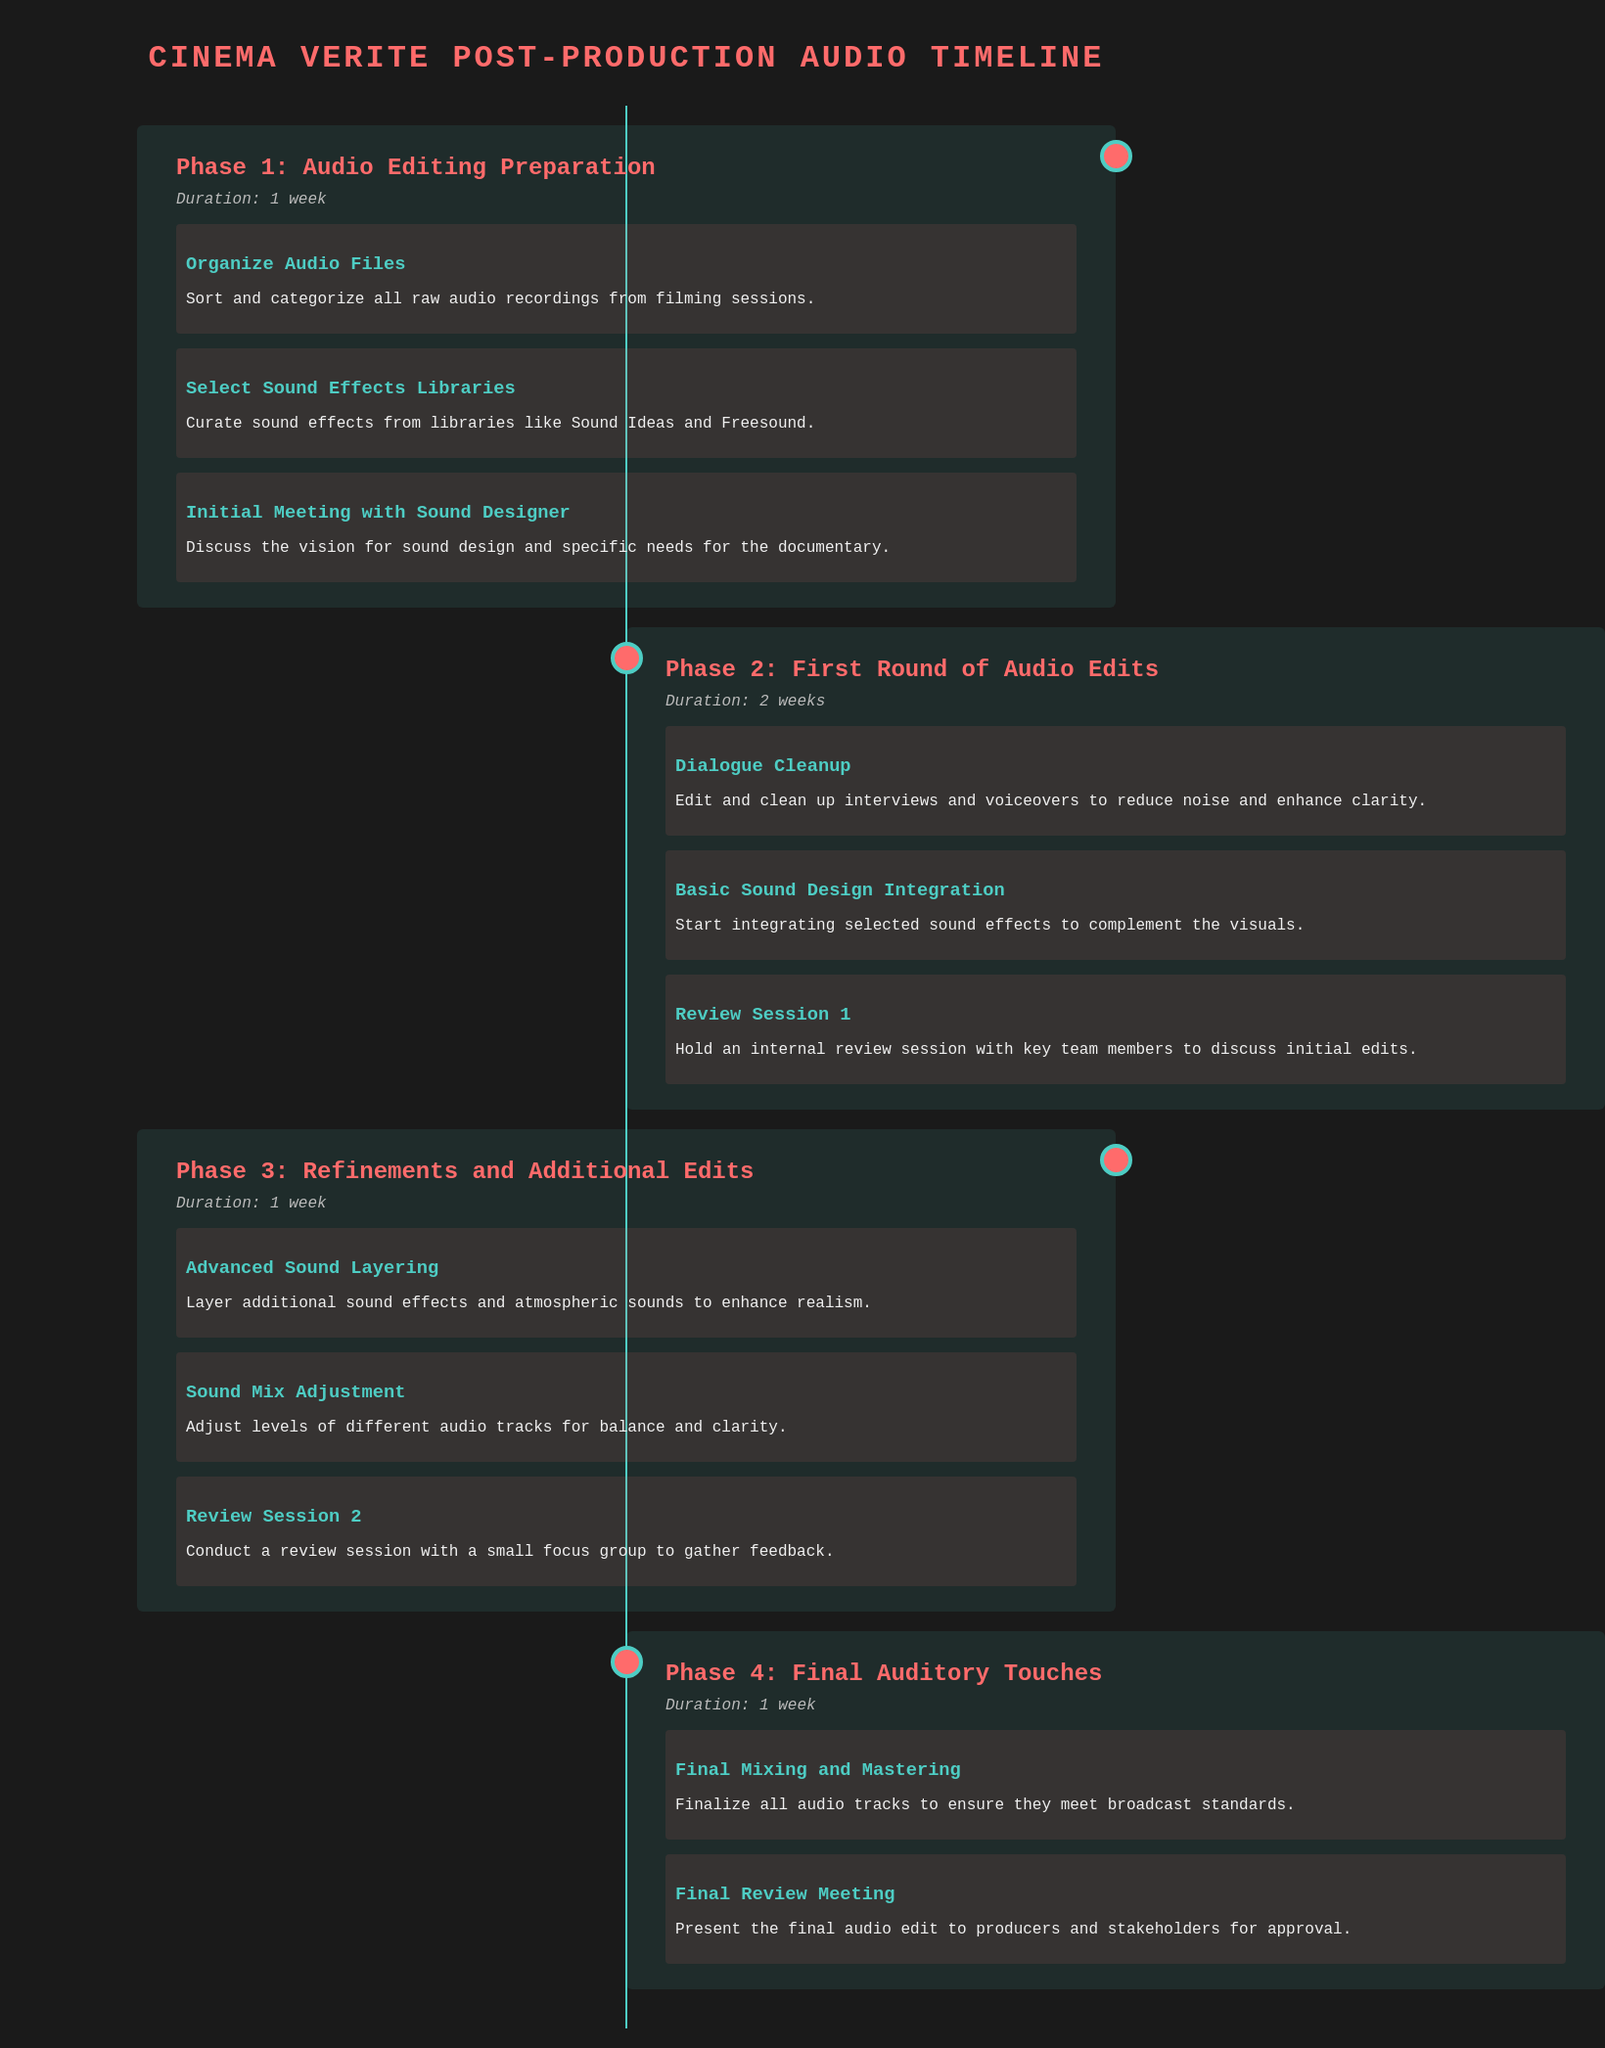What is the duration of Phase 1? Phase 1 lasts for 1 week as indicated in the timeline.
Answer: 1 week What task is performed during the First Round of Audio Edits? The First Round includes tasks like dialogue cleanup and basic sound design integration as noted in the document.
Answer: Dialogue Cleanup How many review sessions are scheduled in the document? The document lists two review sessions: Review Session 1 and Review Session 2.
Answer: 2 What is the focus of the Final Review Meeting? The Final Review Meeting is presented to producers and stakeholders for approval according to the document.
Answer: Approval What is the main goal of Advanced Sound Layering in Phase 3? The document states that the goal is to enhance realism through additional sound effects and atmospheric sounds.
Answer: Enhance realism Which phase involves organizing audio files? Organizing audio files is part of Phase 1 according to the schedule.
Answer: Phase 1 What color is used for the background of the document? The document mentions a background color of dark gray (#1a1a1a).
Answer: Dark gray What is a key task in Phase 4? The final mixing and mastering of audio tracks is emphasized as a key task in Phase 4.
Answer: Final Mixing and Mastering 